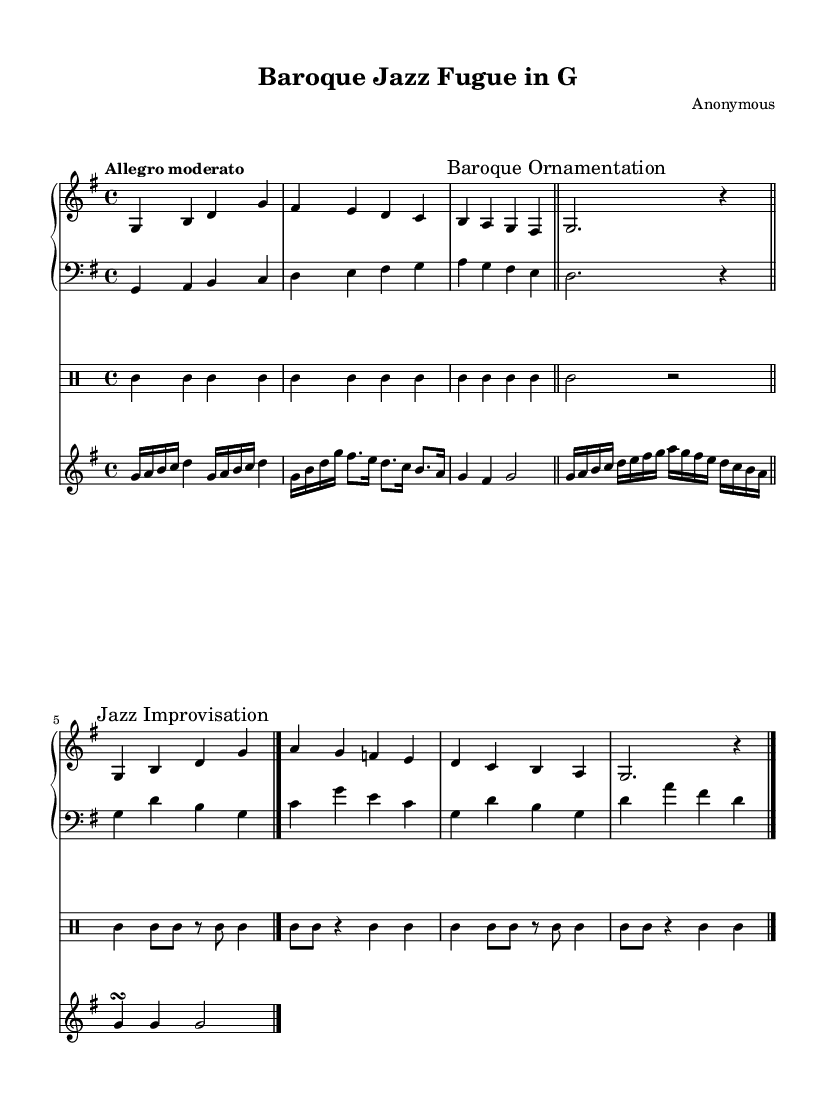What is the key signature of this music? The key signature is indicated by the sharp signs at the beginning of the staff. In this case, there is one sharp, which corresponds to the key of G major.
Answer: G major What is the time signature of the piece? The time signature is represented by the two numbers at the beginning of the staff, indicating 'four beats per measure.' The top number is 4, and the bottom number is also 4.
Answer: 4/4 What is the tempo marking of the piece? The tempo marking, found above the staff, is marked as "Allegro moderato," indicating a moderately fast tempo.
Answer: Allegro moderato What type of improvisation is indicated in the music? The music includes a section marked as "Jazz Improvisation," which signifies that the performers are expected to add their own creative variations over the written material.
Answer: Jazz Improvisation What style of accompaniment does the bass line represent? The bass line is written with quarter notes and eighth notes, structured to provide a supportive rhythm typical of jazz, known as "Walking Bass." This indicates a continuous movement through the harmonic structure.
Answer: Walking Bass What technique is featured in the harpsichord part? The harpsichord part includes rapid, flowing notes that are characteristic of ornamentation, often seen in Baroque music. This section is marked as "Baroque Ornamentation."
Answer: Baroque Ornamentation How many measures are in the piano part before the repeat? The piano part contains a total of four measures leading up to a repeat sign, indicating the end of the first section.
Answer: Four measures 